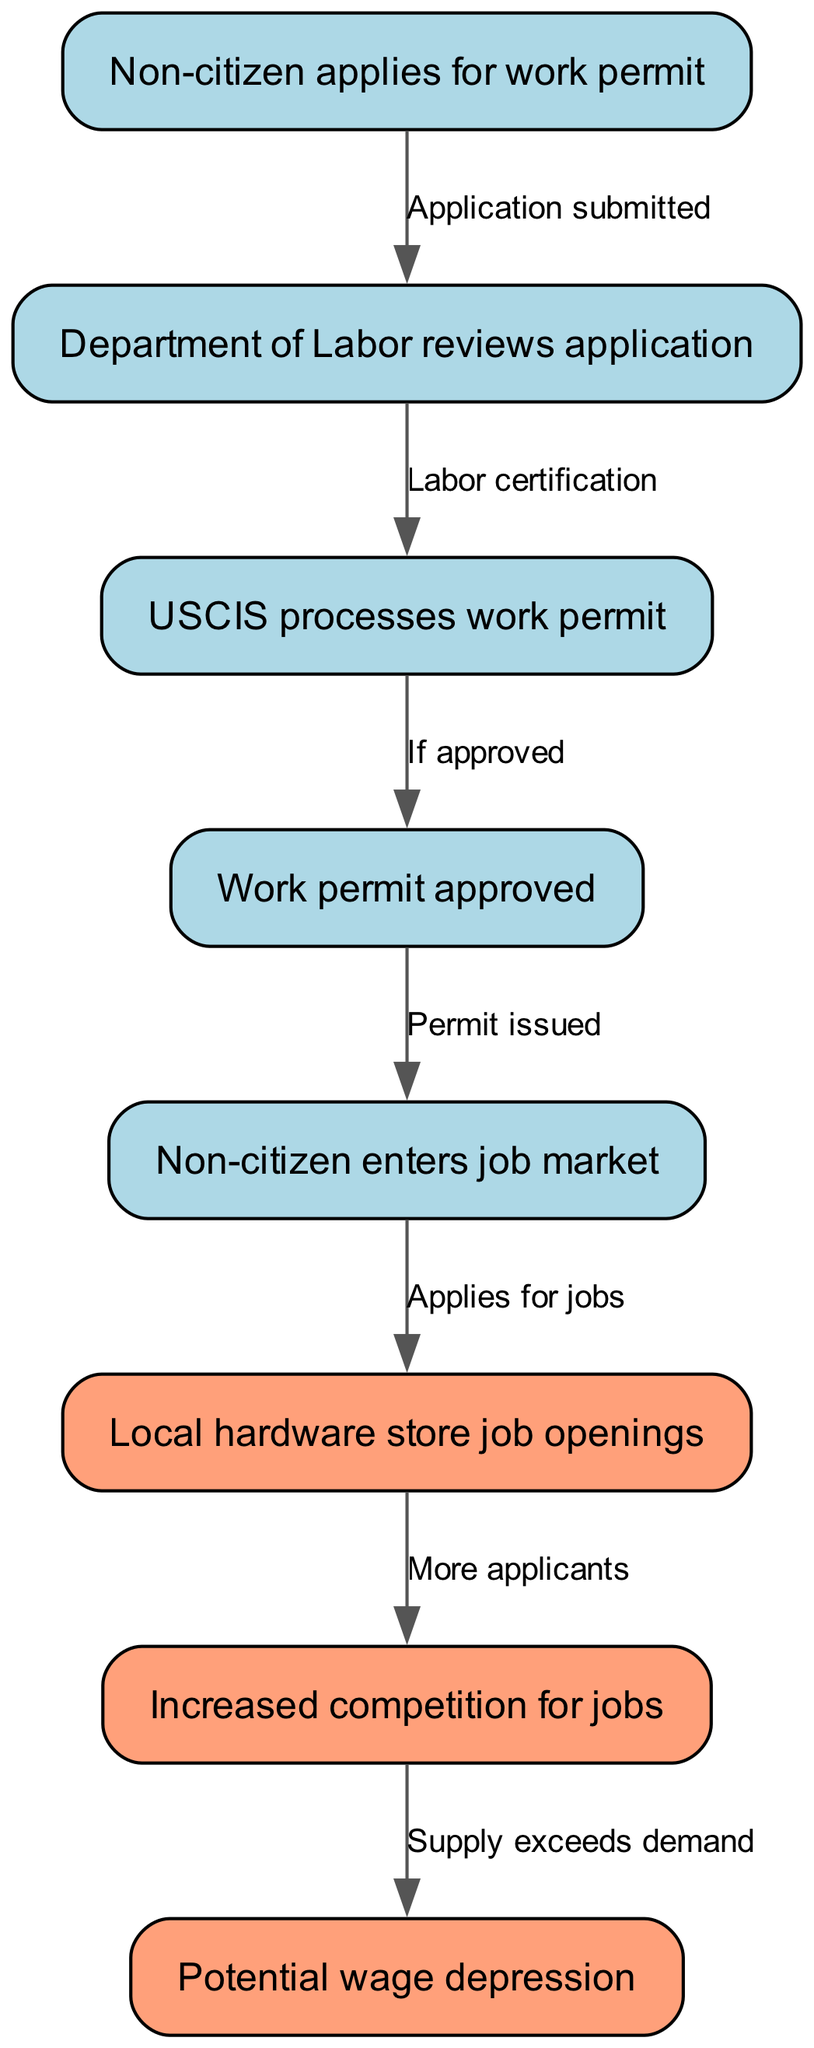What is the first step in the work permit process? The first step is when a non-citizen applies for a work permit. This is indicated as the starting node in the flowchart.
Answer: Non-citizen applies for work permit How many nodes are in the diagram? The diagram includes eight nodes, as seen from the list of steps involved in the work permit process and its impact on job hiring.
Answer: 8 What two actions follow the approval of a work permit? After a work permit is approved, the permit is issued, and the non-citizen then enters the job market, moving through the subsequent nodes in the process.
Answer: Permit issued and Non-citizen enters job market What is the impact of non-citizen job applicants on local hardware store job openings? The entry of non-citizen applicants into the job market leads to increased competition for job openings, as indicated by the edges connecting these nodes.
Answer: Increased competition for jobs What does the supply exceeding demand imply for wages? The flowchart indicates that when the supply of job applicants exceeds demand, it leads to potential wage depression for those jobs. This is drawn from the connections between the relevant nodes.
Answer: Potential wage depression How does approval of the work permit influence job market entry? Once a work permit is approved, it allows the non-citizen to enter the job market, which is shown through the edge connecting these two nodes in the diagram.
Answer: Permit issued What is the relationship between labor certification and USCIS processing? The labor certification step follows the Department of Labor review and precedes the processing of the work permit by USCIS; this is shown as a direct edge connecting these two nodes.
Answer: Labor certification What does the flowchart suggest about local job opportunities? The flowchart suggests that the influx of non-citizens seeking jobs leads to increased competition, which may negatively impact local job opportunities, as indicated by the relationships in the diagram.
Answer: Increased competition for jobs 